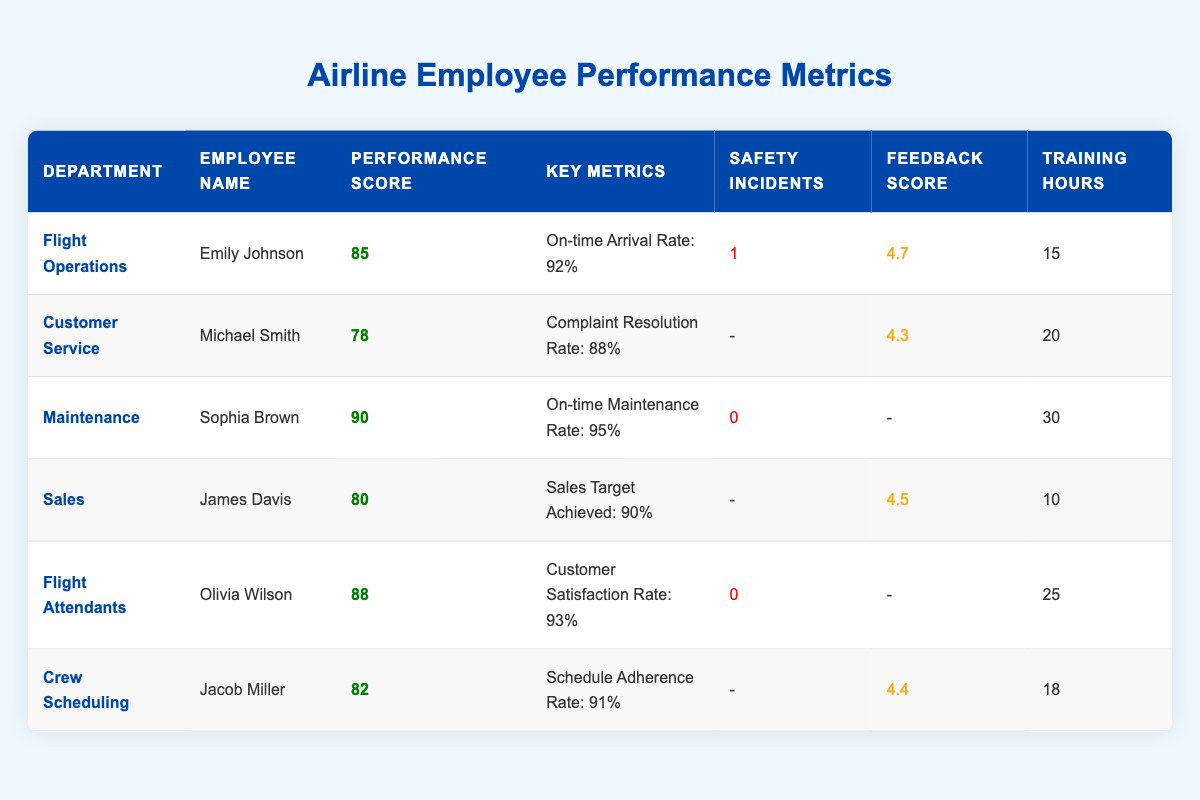What is the performance score of Sophia Brown from the Maintenance department? The table lists Sophia Brown's performance score in the row corresponding to the Maintenance department. It shows a performance score of 90.
Answer: 90 How many safety incidents did Emily Johnson report in Flight Operations? The table specifies the number of safety incidents for Emily Johnson in the Flight Operations section, which shows that there is 1 safety incident.
Answer: 1 Which department has the highest employee performance score? By examining the performance scores, the highest score is 90, attributed to Sophia Brown in the Maintenance department.
Answer: Maintenance What is the average training hours for all employees listed? To calculate the average training hours, sum the training hours: 15 + 20 + 30 + 10 + 25 + 18 = 118. Divide by the number of employees (6), resulting in an average of 118/6 = 19.67 (approximately 20).
Answer: 20 Did Jacob Miller achieve a performance score above 80? Jacob Miller's performance score is listed as 82. Since 82 is greater than 80, the statement is true.
Answer: Yes What is the total number of safety incidents reported across all departments? By adding the safety incidents reported in the table: 1 (Flight Operations) + 0 (Customer Service) + 0 (Maintenance) + 0 (Sales) + 0 (Flight Attendants) + 0 (Crew Scheduling) = 1 total safety incident.
Answer: 1 Is the customer feedback score higher for James Davis than for Michael Smith? Michael Smith's feedback score is 4.3, while James Davis has a feedback score of 4.5. Since 4.5 is greater than 4.3, the statement is false.
Answer: No Which employee has the lowest customer feedback score, and what is that score? Comparing the feedback scores, Michael Smith has a score of 4.3, which is the lowest among all employees listed.
Answer: 4.3 If we compare training hours, who has the maximum training hours, and how many hours do they have? The highest training hours are found in the Maintenance department with 30 hours reported for Sophia Brown.
Answer: Sophia Brown, 30 hours 